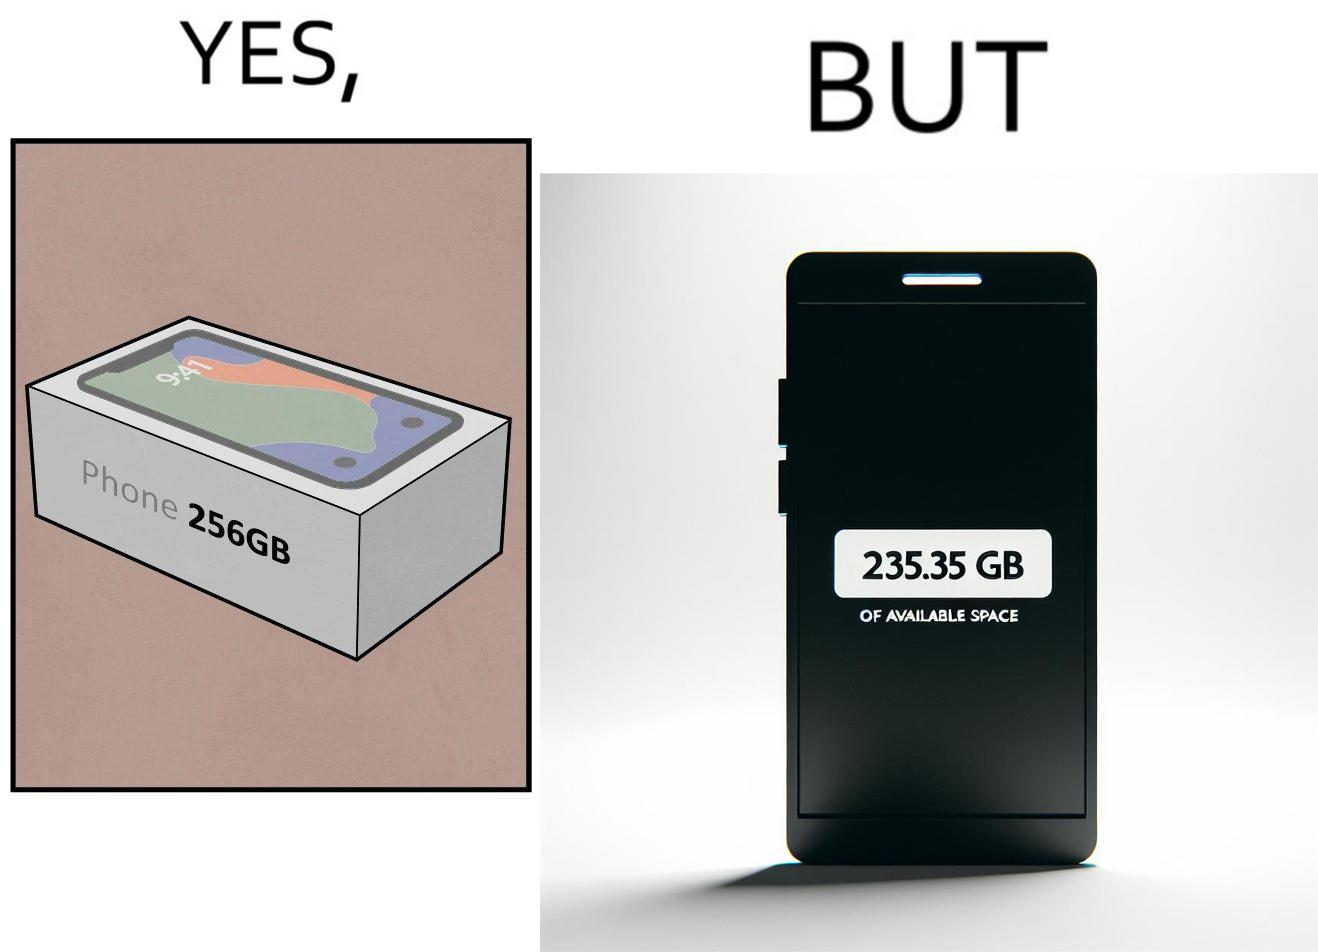Explain why this image is satirical. The images are funny since they show how smartphone manufacturers advertise their smartphones to have a high internal storage space but in reality, the amount of space available to an user is considerably less due to pre-installed software 